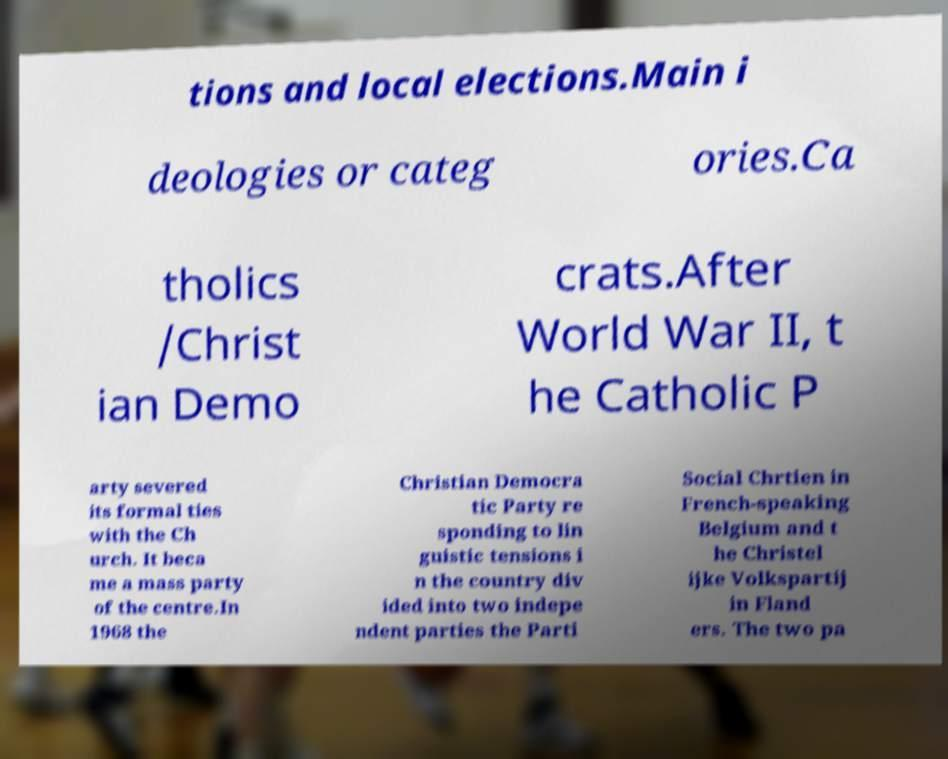For documentation purposes, I need the text within this image transcribed. Could you provide that? tions and local elections.Main i deologies or categ ories.Ca tholics /Christ ian Demo crats.After World War II, t he Catholic P arty severed its formal ties with the Ch urch. It beca me a mass party of the centre.In 1968 the Christian Democra tic Party re sponding to lin guistic tensions i n the country div ided into two indepe ndent parties the Parti Social Chrtien in French-speaking Belgium and t he Christel ijke Volkspartij in Fland ers. The two pa 